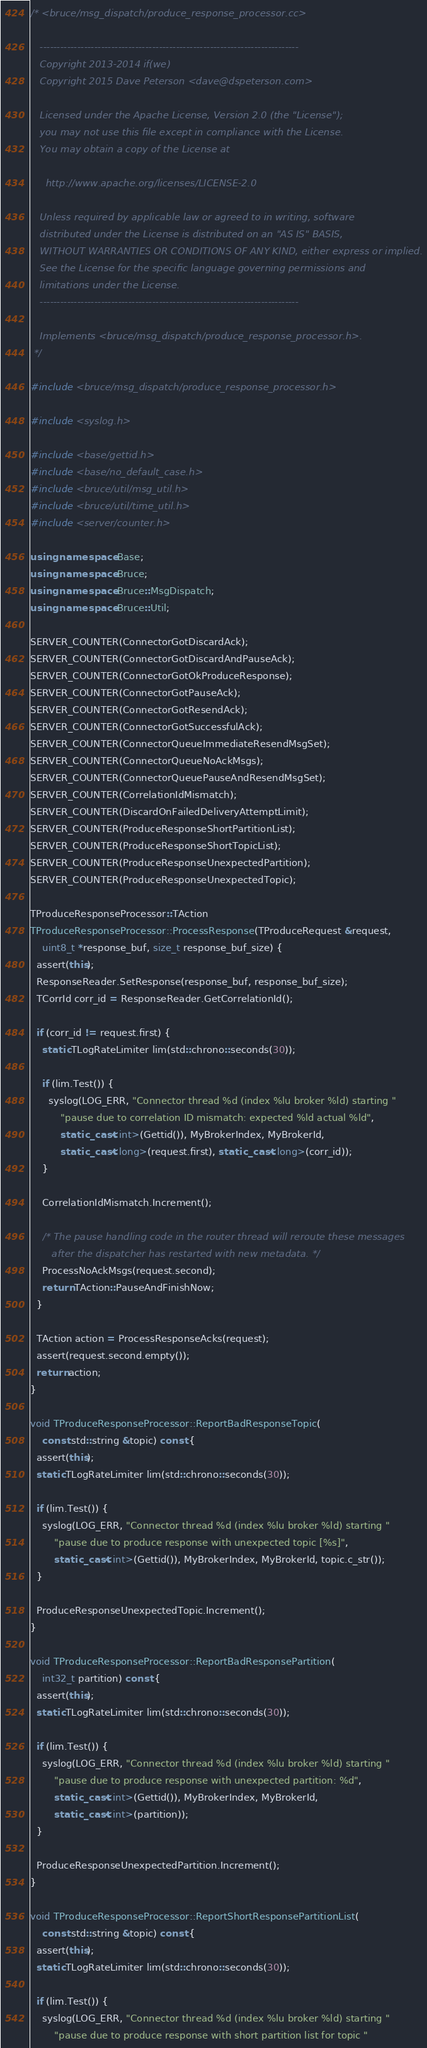<code> <loc_0><loc_0><loc_500><loc_500><_C++_>/* <bruce/msg_dispatch/produce_response_processor.cc>

   ----------------------------------------------------------------------------
   Copyright 2013-2014 if(we)
   Copyright 2015 Dave Peterson <dave@dspeterson.com>

   Licensed under the Apache License, Version 2.0 (the "License");
   you may not use this file except in compliance with the License.
   You may obtain a copy of the License at

     http://www.apache.org/licenses/LICENSE-2.0

   Unless required by applicable law or agreed to in writing, software
   distributed under the License is distributed on an "AS IS" BASIS,
   WITHOUT WARRANTIES OR CONDITIONS OF ANY KIND, either express or implied.
   See the License for the specific language governing permissions and
   limitations under the License.
   ----------------------------------------------------------------------------

   Implements <bruce/msg_dispatch/produce_response_processor.h>.
 */

#include <bruce/msg_dispatch/produce_response_processor.h>

#include <syslog.h>

#include <base/gettid.h>
#include <base/no_default_case.h>
#include <bruce/util/msg_util.h>
#include <bruce/util/time_util.h>
#include <server/counter.h>

using namespace Base;
using namespace Bruce;
using namespace Bruce::MsgDispatch;
using namespace Bruce::Util;

SERVER_COUNTER(ConnectorGotDiscardAck);
SERVER_COUNTER(ConnectorGotDiscardAndPauseAck);
SERVER_COUNTER(ConnectorGotOkProduceResponse);
SERVER_COUNTER(ConnectorGotPauseAck);
SERVER_COUNTER(ConnectorGotResendAck);
SERVER_COUNTER(ConnectorGotSuccessfulAck);
SERVER_COUNTER(ConnectorQueueImmediateResendMsgSet);
SERVER_COUNTER(ConnectorQueueNoAckMsgs);
SERVER_COUNTER(ConnectorQueuePauseAndResendMsgSet);
SERVER_COUNTER(CorrelationIdMismatch);
SERVER_COUNTER(DiscardOnFailedDeliveryAttemptLimit);
SERVER_COUNTER(ProduceResponseShortPartitionList);
SERVER_COUNTER(ProduceResponseShortTopicList);
SERVER_COUNTER(ProduceResponseUnexpectedPartition);
SERVER_COUNTER(ProduceResponseUnexpectedTopic);

TProduceResponseProcessor::TAction
TProduceResponseProcessor::ProcessResponse(TProduceRequest &request,
    uint8_t *response_buf, size_t response_buf_size) {
  assert(this);
  ResponseReader.SetResponse(response_buf, response_buf_size);
  TCorrId corr_id = ResponseReader.GetCorrelationId();

  if (corr_id != request.first) {
    static TLogRateLimiter lim(std::chrono::seconds(30));

    if (lim.Test()) {
      syslog(LOG_ERR, "Connector thread %d (index %lu broker %ld) starting "
          "pause due to correlation ID mismatch: expected %ld actual %ld",
          static_cast<int>(Gettid()), MyBrokerIndex, MyBrokerId,
          static_cast<long>(request.first), static_cast<long>(corr_id));
    }

    CorrelationIdMismatch.Increment();

    /* The pause handling code in the router thread will reroute these messages
       after the dispatcher has restarted with new metadata. */
    ProcessNoAckMsgs(request.second);
    return TAction::PauseAndFinishNow;
  }

  TAction action = ProcessResponseAcks(request);
  assert(request.second.empty());
  return action;
}

void TProduceResponseProcessor::ReportBadResponseTopic(
    const std::string &topic) const {
  assert(this);
  static TLogRateLimiter lim(std::chrono::seconds(30));

  if (lim.Test()) {
    syslog(LOG_ERR, "Connector thread %d (index %lu broker %ld) starting "
        "pause due to produce response with unexpected topic [%s]",
        static_cast<int>(Gettid()), MyBrokerIndex, MyBrokerId, topic.c_str());
  }

  ProduceResponseUnexpectedTopic.Increment();
}

void TProduceResponseProcessor::ReportBadResponsePartition(
    int32_t partition) const {
  assert(this);
  static TLogRateLimiter lim(std::chrono::seconds(30));

  if (lim.Test()) {
    syslog(LOG_ERR, "Connector thread %d (index %lu broker %ld) starting "
        "pause due to produce response with unexpected partition: %d",
        static_cast<int>(Gettid()), MyBrokerIndex, MyBrokerId,
        static_cast<int>(partition));
  }

  ProduceResponseUnexpectedPartition.Increment();
}

void TProduceResponseProcessor::ReportShortResponsePartitionList(
    const std::string &topic) const {
  assert(this);
  static TLogRateLimiter lim(std::chrono::seconds(30));

  if (lim.Test()) {
    syslog(LOG_ERR, "Connector thread %d (index %lu broker %ld) starting "
        "pause due to produce response with short partition list for topic "</code> 